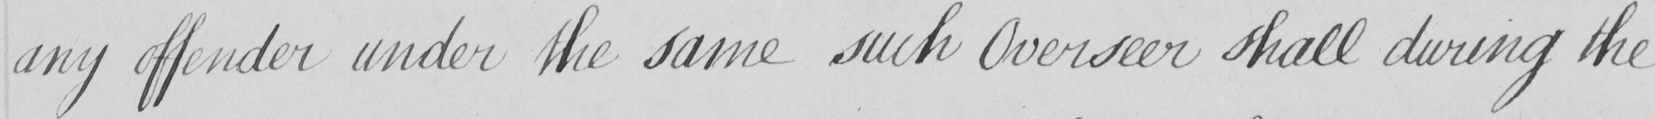What does this handwritten line say? any offender under the same such Overseer shall during the 